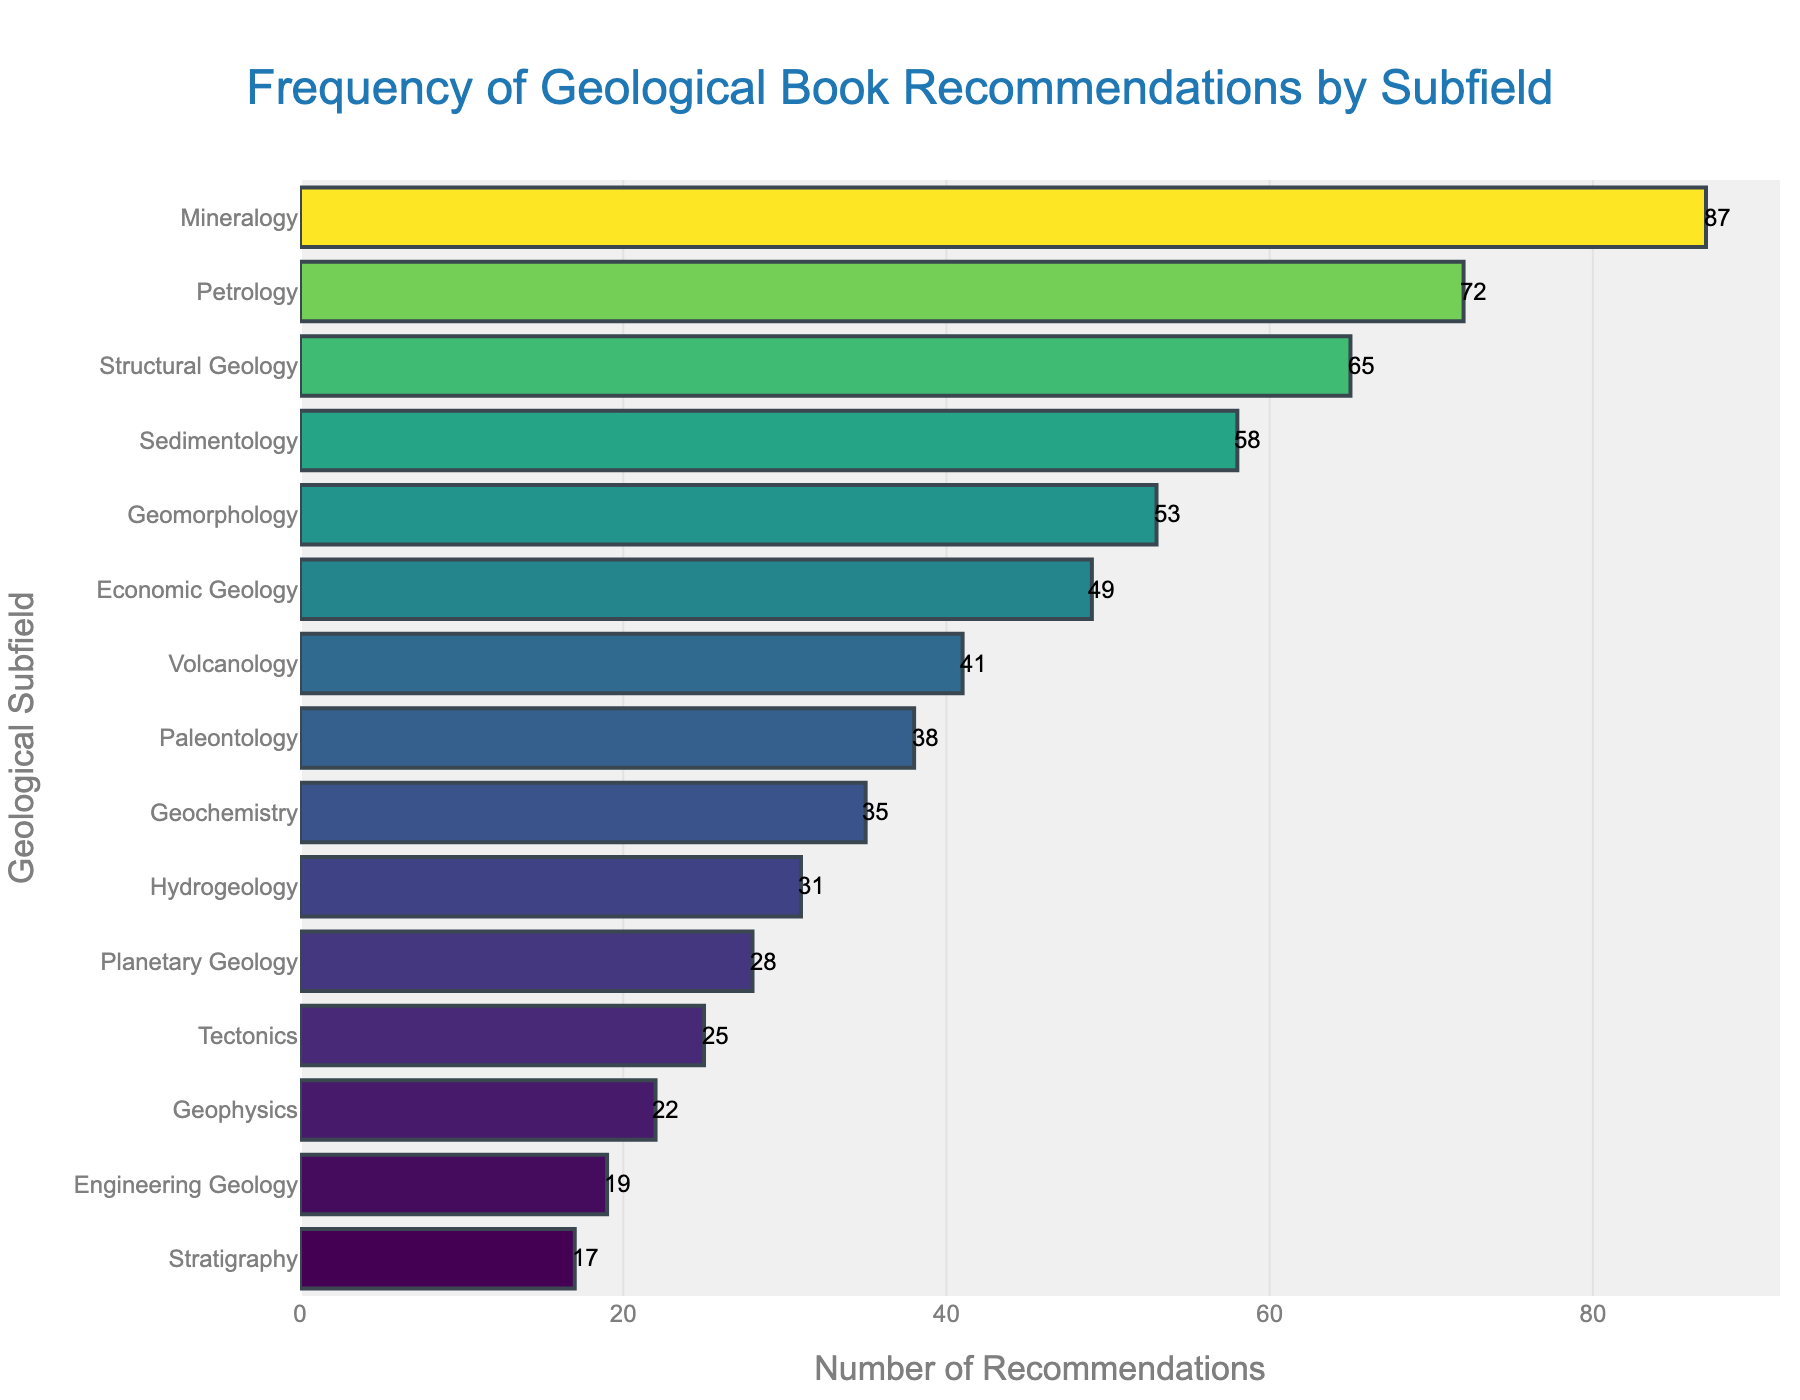What subfield has the highest number of book recommendations? To find the subfield with the highest recommendations, look for the longest bar in the chart. This corresponds to "Mineralogy" with 87 recommendations.
Answer: Mineralogy Which subfield has fewer recommendations, Tectonics or Hydrogeology? Compare the lengths of the bars corresponding to Tectonics and Hydrogeology. Tectonics has 25 recommendations, while Hydrogeology has 31 recommendations. Tectonics has fewer recommendations.
Answer: Tectonics What is the sum of book recommendations for Structural Geology and Petrology? Find the number of recommendations for Structural Geology (65) and Petrology (72), then add them together. 65 + 72 = 137.
Answer: 137 How many more recommendations does Volcanology have compared to Paleontology? Determine the number of recommendations for Volcanology (41) and Paleontology (38). Subtract Paleontology's recommendations from Volcanology's: 41 - 38 = 3.
Answer: 3 Which subfield has the fewest recommendations, and how many are there? Identify the shortest bar in the chart. This corresponds to Stratigraphy, which has 17 recommendations.
Answer: Stratigraphy, 17 